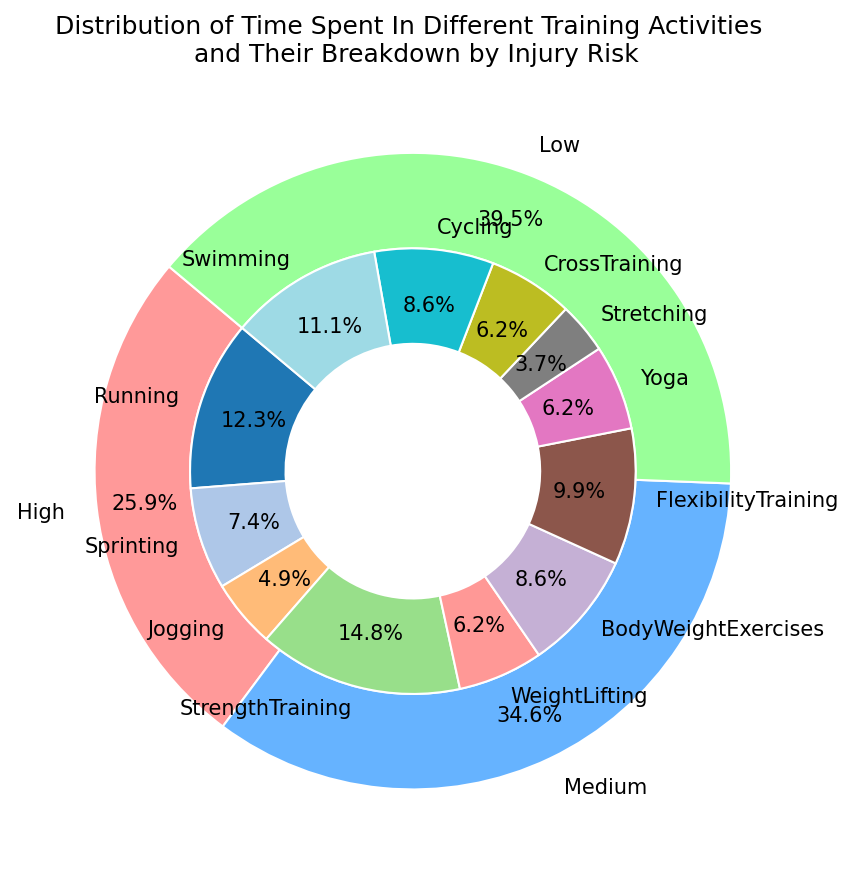Who spent more time on training activities, "High" risk or "Low" risk? The "High" risk activities had a total time of 21 (Running: 10 + Sprinting: 6 + WeightLifting: 5). The "Low" risk activities had a total time of 23 (BodyWeightExercises: 7 + FlexibilityTraining: 8 + Yoga: 5 + Stretching: 3). Compare the two sums: 21 < 23.
Answer: Low risk Among the "Medium" risk activities, which one had the highest total time? The "Medium" risk activities are Jogging (4), StrengthTraining (12), CrossTraining (5), and Cycling (7). The highest total time among these is StrengthTraining with 12 hours.
Answer: StrengthTraining What percentage of the total training time is spent on "Low" risk activities? The total training time across all activities is 81 hours. The total time spent on "Low" risk activities is 23 hours. Calculate the percentage: (23/81)*100.
Answer: 28.4% How does the time spent on "StrengthTraining" compare to the time spent on "Swimming"? "StrengthTraining" has 12 hours and "Swimming" has 9 hours. Since 12 > 9, more time is spent on "StrengthTraining".
Answer: More What is the total training time for "Medium" risk activities? The activities are Jogging (4), StrengthTraining (12), CrossTraining (5), and Cycling (7). Sum these values: 4 + 12 + 5 + 7.
Answer: 28 Which activity within the "Low" risk category has the smallest total time? The "Low" risk activities are BodyWeightExercises (7), FlexibilityTraining (8), Yoga (5), and Stretching (3). The smallest value is Stretching with 3 hours.
Answer: Stretching Is the time spent on "Running" greater than the combined time spent on "Yoga" and "Stretching"? "Running" has 10 hours. "Yoga" and "Stretching" combined have 5 + 3 = 8 hours. Since 10 > 8, the time spent on "Running" is greater.
Answer: Yes Calculate the average time spent on "High" risk activities. The "High" risk activities are Running (10), Sprinting (6), and WeightLifting (5). Sum these values: 10 + 6 + 5 = 21. The average is 21/3.
Answer: 7 What is the largest proportion of time spent within any single "Medium" risk activity? The "Medium" risk activities are Jogging (4), StrengthTraining (12), CrossTraining (5), and Cycling (7). StrengthTraining has the highest time (12). Calculate its proportion: (12/28)*100.
Answer: 42.9% Which has more activities, "Low" risk or "Medium" risk? "Low" risk has BodyWeightExercises, FlexibilityTraining, Yoga, and Stretching, totaling 4 activities. "Medium" risk has Jogging, StrengthTraining, CrossTraining, and Cycling, also totaling 4 activities. Compare the two counts: 4 = 4.
Answer: Equal 